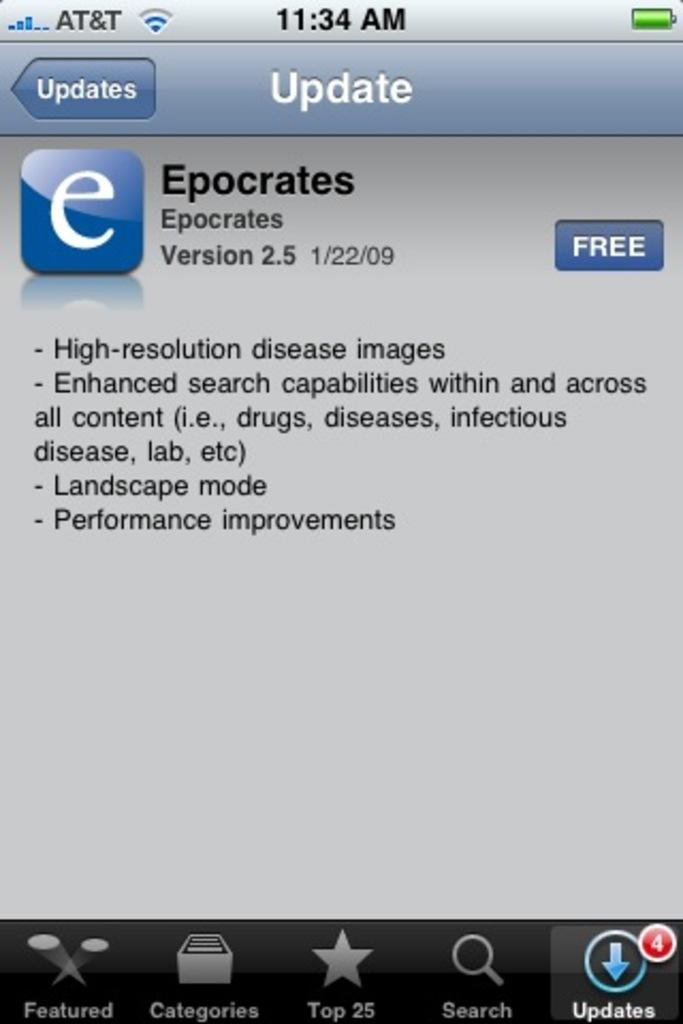<image>
Render a clear and concise summary of the photo. Phone screen showing an update for Epocrates for version 2.5 